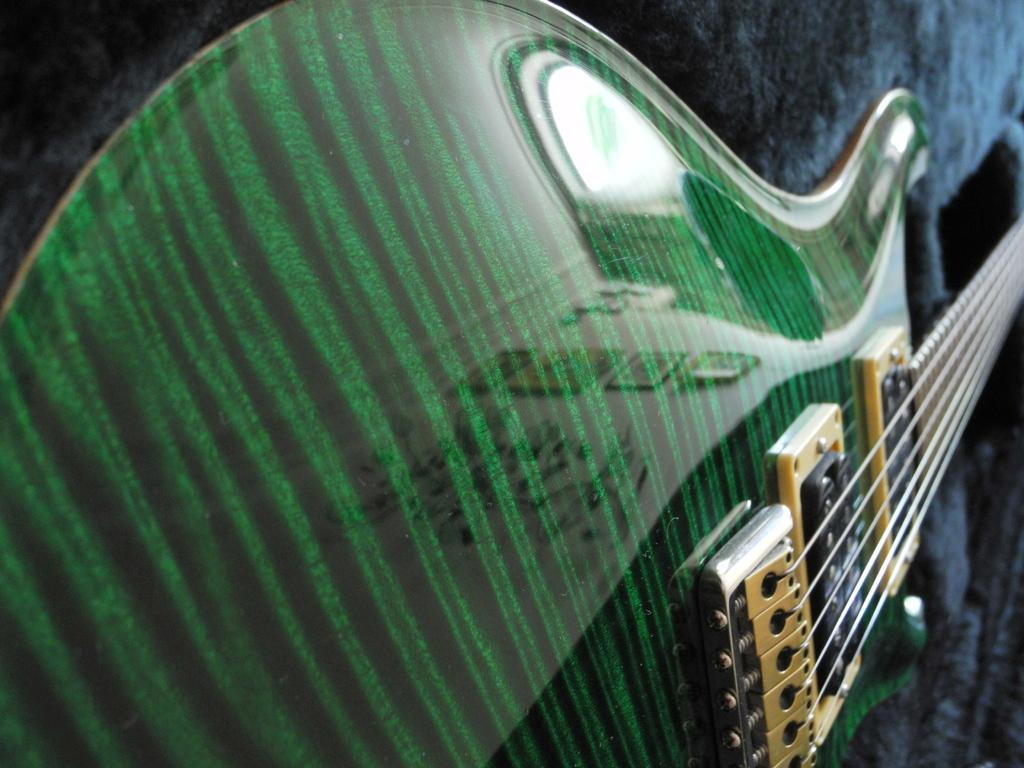What musical instrument is in the image? There is a guitar in the image. What color is the guitar? The guitar is green. What are the guitar's features that allow it to be played? The guitar has strings and tuners. On what is the guitar placed? The guitar is placed on a towel. How does the towel appear in the image? The towel has lots of fur on it. Can you tell me how many friends are playing the drum in the image? There is no drum or friends present in the image; it features a green guitar placed on a furry towel. 